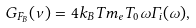<formula> <loc_0><loc_0><loc_500><loc_500>G _ { F _ { B } } ( \nu ) = 4 k _ { B } T m _ { e } T _ { 0 } \omega \Gamma _ { i } ( \omega ) ,</formula> 